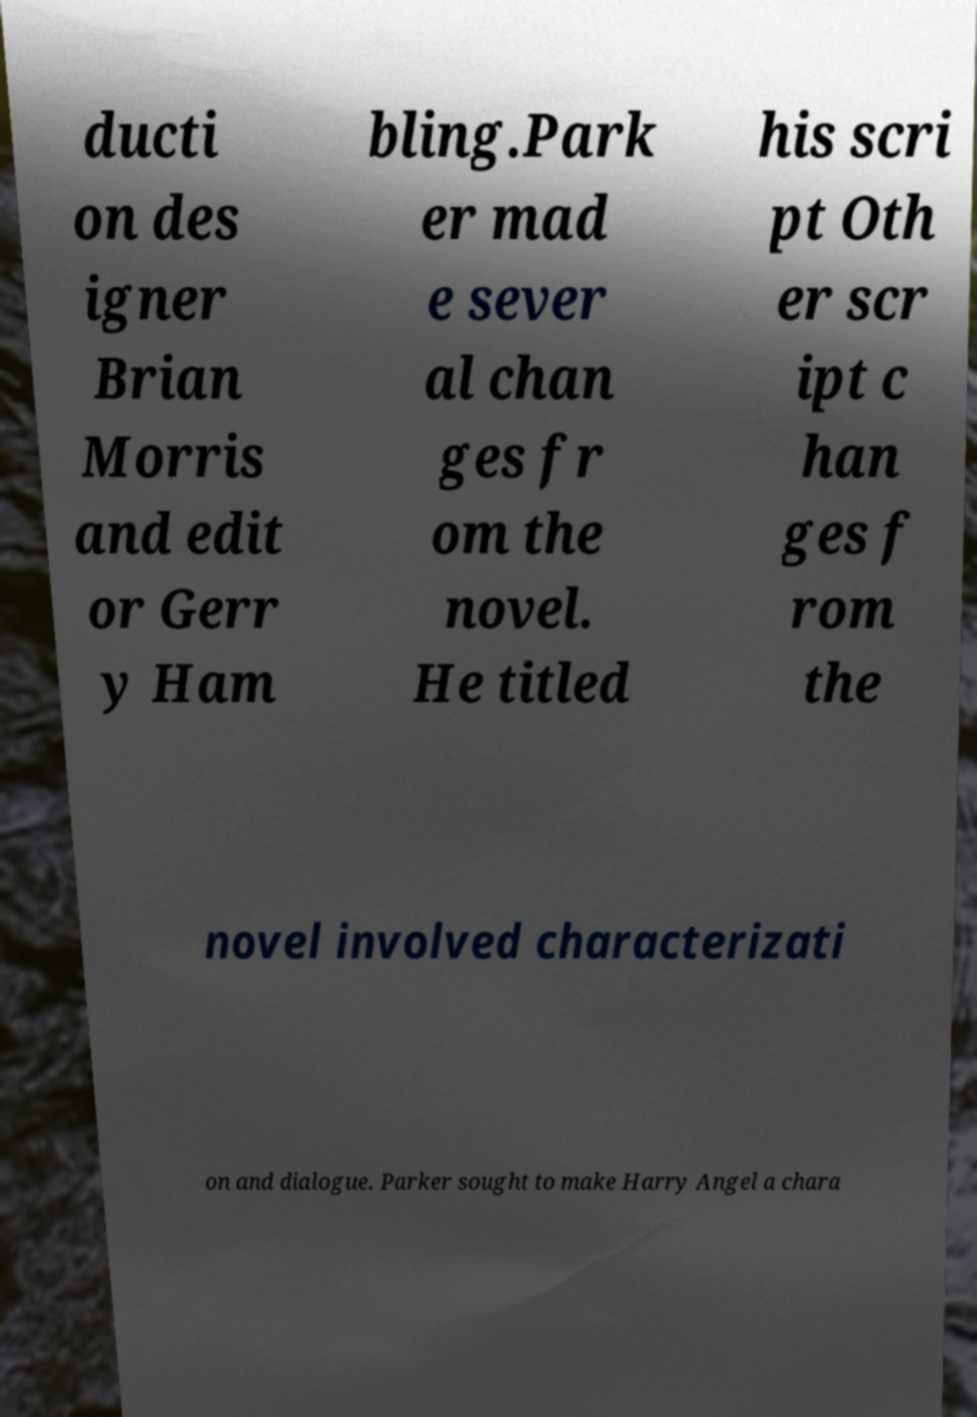I need the written content from this picture converted into text. Can you do that? ducti on des igner Brian Morris and edit or Gerr y Ham bling.Park er mad e sever al chan ges fr om the novel. He titled his scri pt Oth er scr ipt c han ges f rom the novel involved characterizati on and dialogue. Parker sought to make Harry Angel a chara 